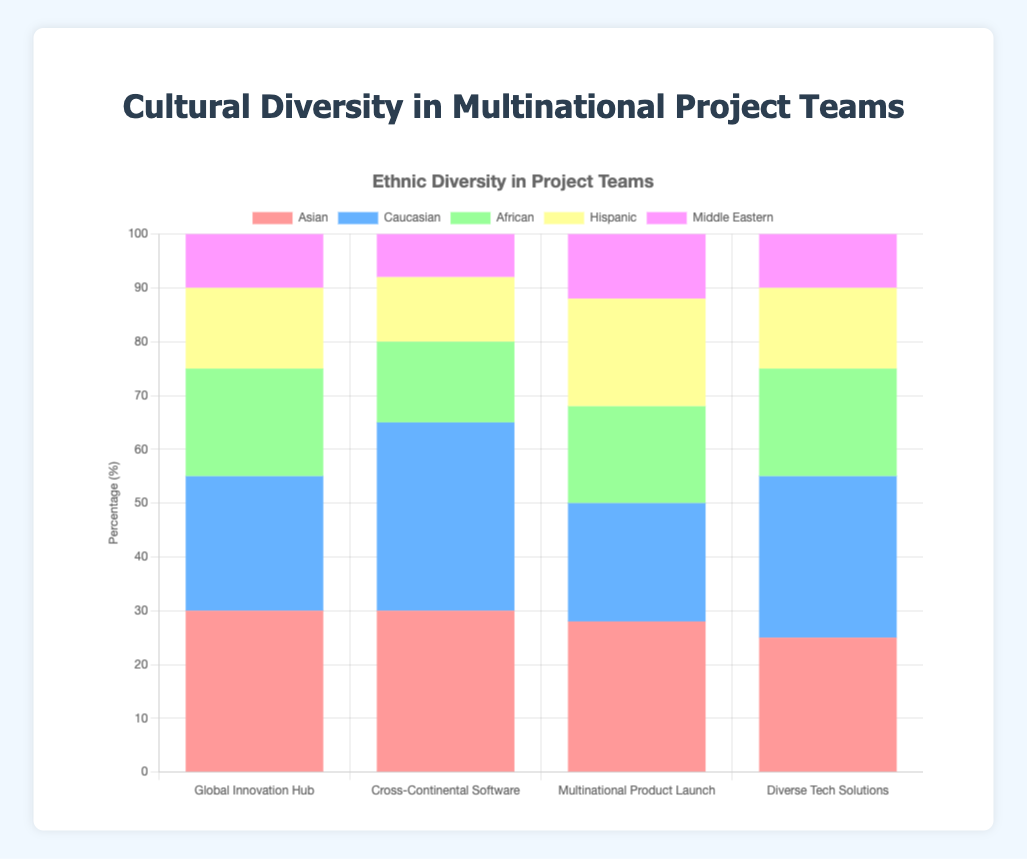What is the title of the figure? The title is located at the top of the figure and usually summarizes the main topic of the data presented.
Answer: Cultural Diversity in Multinational Project Teams What are the labels on the x-axis? The x-axis represents the different project teams in the data. Each label is a team's name.
Answer: Global Innovation Hub, Cross-Continental Software, Multinational Product Launch, Diverse Tech Solutions What is the percentage of Caucasians in the 'Global Innovation Hub' team? Find the bar labeled "Caucasian" for the 'Global Innovation Hub' team and read the value from the y-axis.
Answer: 25% Which team has the highest percentage of Hispanics? Compare the heights of the bars labeled "Hispanic" across all teams and identify the highest one.
Answer: Multinational Product Launch What is the total percentage of all ethnicities in the 'Cross-Continental Software' team? Sum the percentages of all ethnicities in the 'Cross-Continental Software' team.
Answer: 100% How does the percentage of Africans in 'Diverse Tech Solutions' compare to 'Global Innovation Hub'? Look at the bars labeled "African" for both teams and compare their heights. Both have the same height, indicating equal percentages.
Answer: Equal (20%) What is the difference in percentage of Middle Eastern members between 'Global Innovation Hub' and 'Cross-Continental Software'? Subtract the percentage of 'Cross-Continental Software' from 'Global Innovation Hub' for the Middle Eastern category.
Answer: 2% Among which ethnic group do 'Multinational Product Launch' and 'Cross-Continental Software' have the closest percentages? Check the values for each ethnic group and compare the differences between the two teams.
Answer: Middle Eastern (both 12%) Which team shows the most balanced ethnic diversity? Analyze the variations in heights (percentages) for each team and select the one with the most even distribution across all ethnic groups.
Answer: Multinational Product Launch 